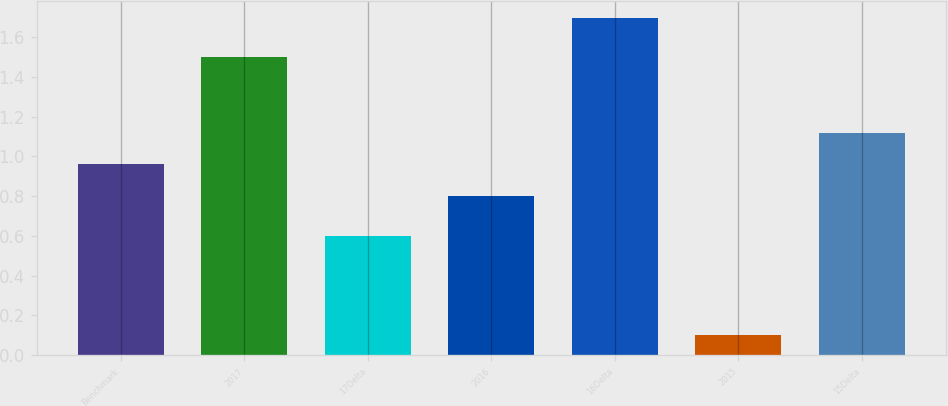<chart> <loc_0><loc_0><loc_500><loc_500><bar_chart><fcel>Benchmark<fcel>2017<fcel>17Delta<fcel>2016<fcel>16Delta<fcel>2015<fcel>15Delta<nl><fcel>0.96<fcel>1.5<fcel>0.6<fcel>0.8<fcel>1.7<fcel>0.1<fcel>1.12<nl></chart> 